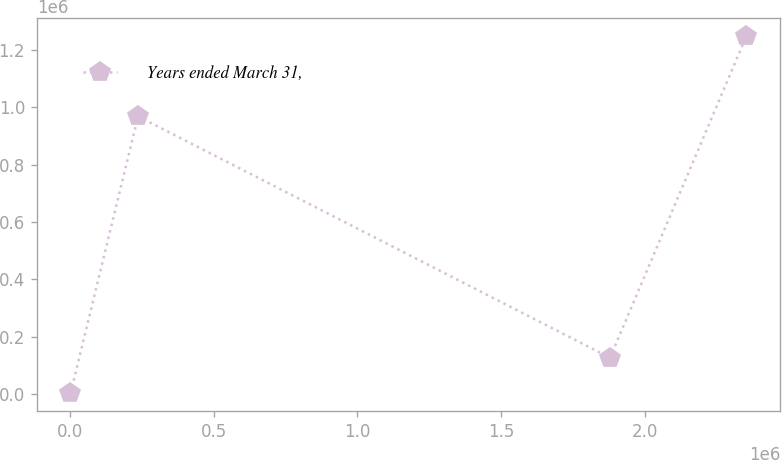<chart> <loc_0><loc_0><loc_500><loc_500><line_chart><ecel><fcel>Years ended March 31,<nl><fcel>2205.61<fcel>1648.54<nl><fcel>237409<fcel>968802<nl><fcel>1.87971e+06<fcel>126389<nl><fcel>2.35424e+06<fcel>1.24906e+06<nl></chart> 